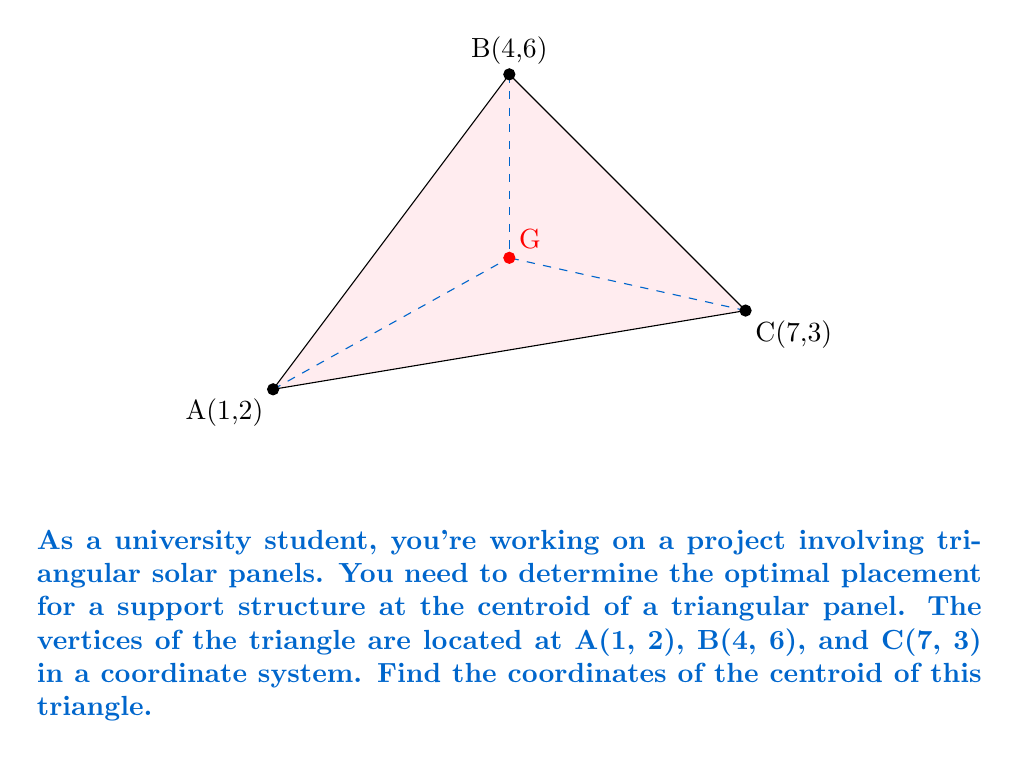Show me your answer to this math problem. To find the centroid of a triangle, we can use the formula:

$$G_x = \frac{x_1 + x_2 + x_3}{3}, \quad G_y = \frac{y_1 + y_2 + y_3}{3}$$

Where $(G_x, G_y)$ are the coordinates of the centroid, and $(x_1, y_1)$, $(x_2, y_2)$, and $(x_3, y_3)$ are the coordinates of the three vertices.

Given:
A(1, 2), B(4, 6), C(7, 3)

Step 1: Calculate $G_x$
$$G_x = \frac{x_1 + x_2 + x_3}{3} = \frac{1 + 4 + 7}{3} = \frac{12}{3} = 4$$

Step 2: Calculate $G_y$
$$G_y = \frac{y_1 + y_2 + y_3}{3} = \frac{2 + 6 + 3}{3} = \frac{11}{3}$$

Therefore, the coordinates of the centroid G are (4, 11/3).
Answer: (4, 11/3) 